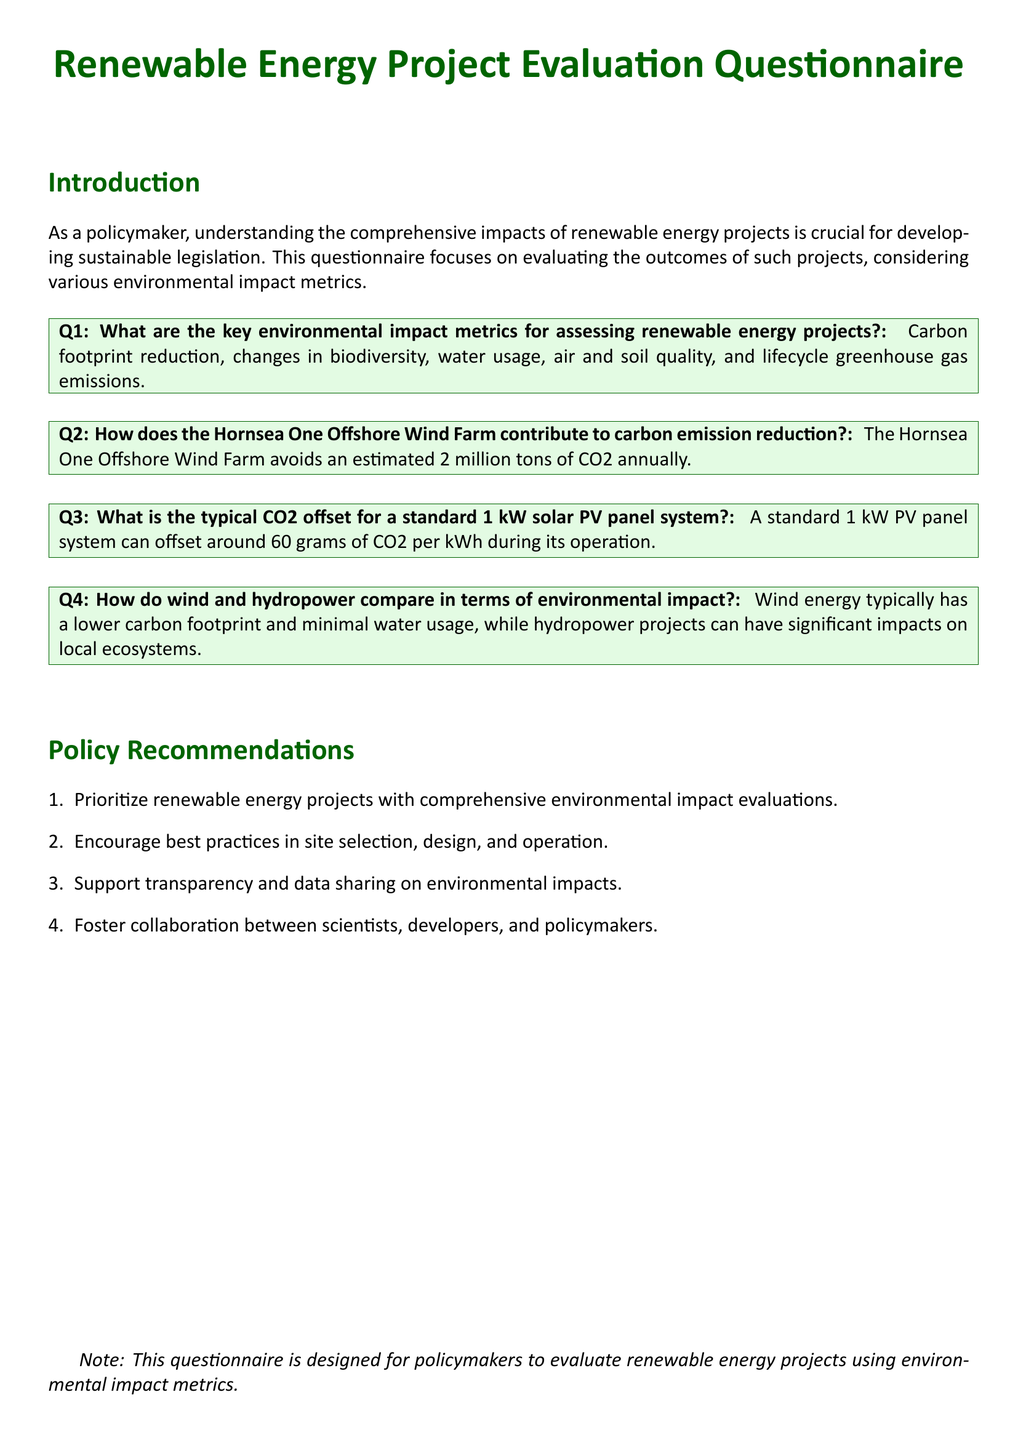What are the key environmental impact metrics? The key environmental impact metrics for assessing renewable energy projects include various factors such as carbon footprint reduction and biodiversity, as stated in the document.
Answer: Carbon footprint reduction, changes in biodiversity, water usage, air and soil quality, and lifecycle greenhouse gas emissions How much CO2 does Hornsea One Offshore Wind Farm avoid? The document specifies a significant figure regarding the CO2 avoidance, providing a clear numerical impact of the project.
Answer: 2 million tons What is the CO2 offset for a 1 kW solar PV panel? The document presents a specific measure relating to the environmental benefits of solar energy systems which is useful for understanding their impact.
Answer: 60 grams per kWh Which energy source has lower water usage? A comparison in the document evaluates the environmental impacts of wind and hydropower, particularly in terms of water usage.
Answer: Wind What type of projects should be prioritized? The policy recommendations section outlines key project types that need attention for sustainable development based on environmental impacts.
Answer: Renewable energy projects with comprehensive environmental impact evaluations What is encouraged in best practices? The document suggests best practices relevant to site selection, design, and operation for renewable energy projects, outlining key aspects for development.
Answer: Site selection, design, and operation Who should collaborate in renewable energy projects? The document mentions various stakeholders that should work together, emphasizing the importance of collaboration for effective project outcomes.
Answer: Scientists, developers, and policymakers 